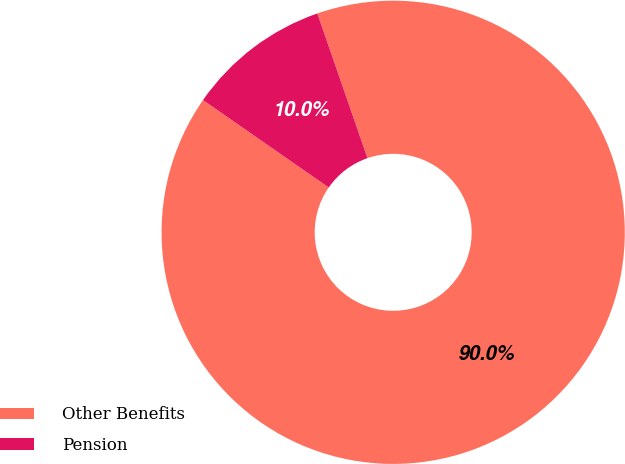Convert chart. <chart><loc_0><loc_0><loc_500><loc_500><pie_chart><fcel>Other Benefits<fcel>Pension<nl><fcel>89.98%<fcel>10.02%<nl></chart> 